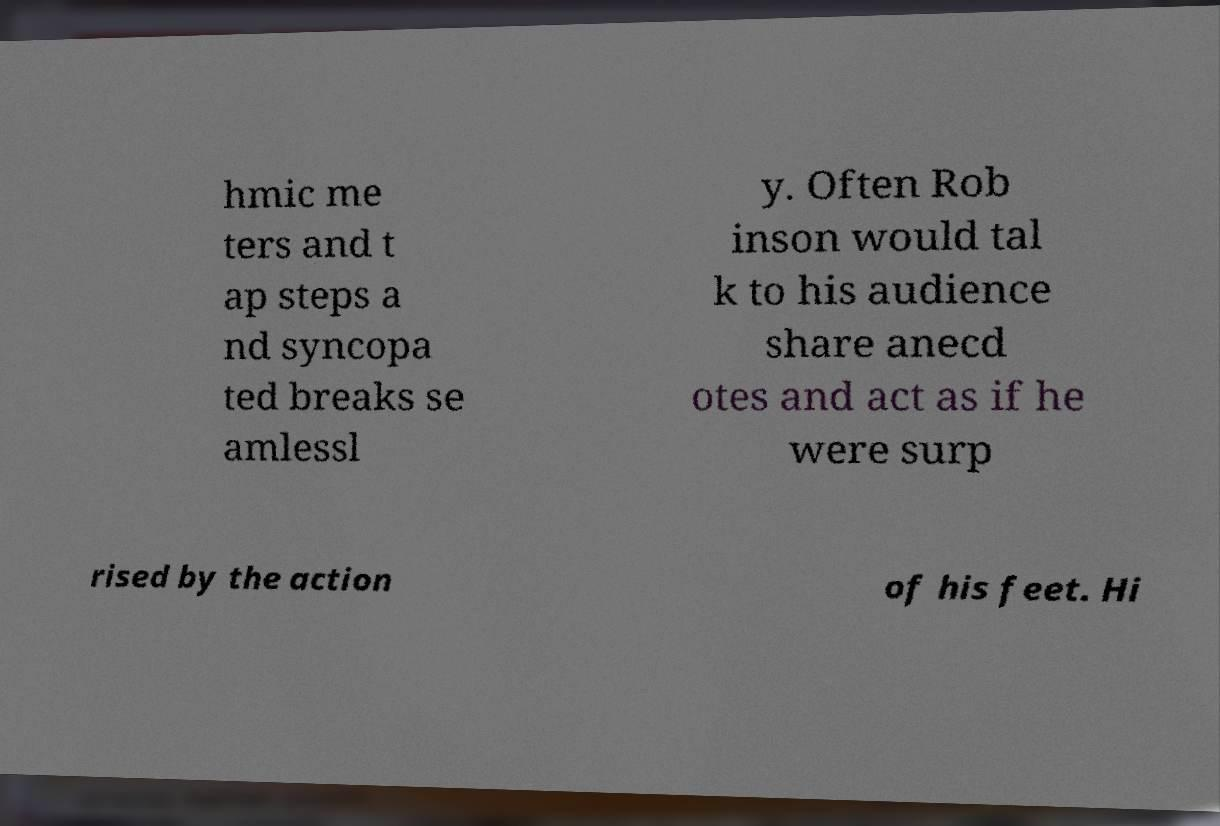For documentation purposes, I need the text within this image transcribed. Could you provide that? hmic me ters and t ap steps a nd syncopa ted breaks se amlessl y. Often Rob inson would tal k to his audience share anecd otes and act as if he were surp rised by the action of his feet. Hi 